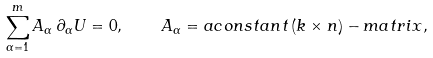Convert formula to latex. <formula><loc_0><loc_0><loc_500><loc_500>\sum _ { \alpha = 1 } ^ { m } A _ { \alpha } \, \partial _ { \alpha } U = 0 , \quad A _ { \alpha } = a c o n s t a n t \, ( k \times n ) - m a t r i x ,</formula> 